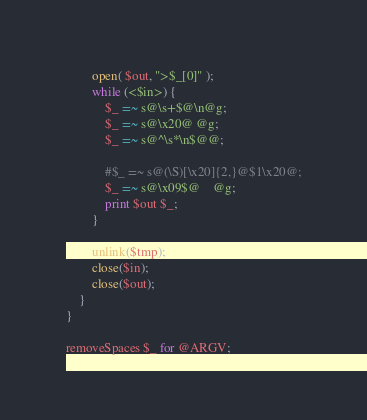Convert code to text. <code><loc_0><loc_0><loc_500><loc_500><_Perl_>        open( $out, ">$_[0]" );
        while (<$in>) {
            $_ =~ s@\s+$@\n@g;
            $_ =~ s@\x20@ @g;
            $_ =~ s@^\s*\n$@@;

            #$_ =~ s@(\S)[\x20]{2,}@$1\x20@;
            $_ =~ s@\x09$@    @g;
            print $out $_;
        }

        unlink($tmp);
        close($in);
        close($out);
    }
}

removeSpaces $_ for @ARGV;

</code> 